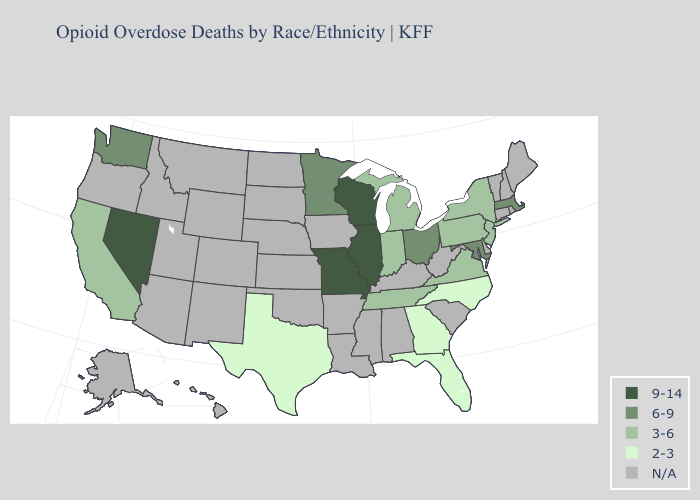Name the states that have a value in the range N/A?
Answer briefly. Alabama, Alaska, Arizona, Arkansas, Colorado, Connecticut, Delaware, Hawaii, Idaho, Iowa, Kansas, Kentucky, Louisiana, Maine, Mississippi, Montana, Nebraska, New Hampshire, New Mexico, North Dakota, Oklahoma, Oregon, Rhode Island, South Carolina, South Dakota, Utah, Vermont, West Virginia, Wyoming. Name the states that have a value in the range N/A?
Be succinct. Alabama, Alaska, Arizona, Arkansas, Colorado, Connecticut, Delaware, Hawaii, Idaho, Iowa, Kansas, Kentucky, Louisiana, Maine, Mississippi, Montana, Nebraska, New Hampshire, New Mexico, North Dakota, Oklahoma, Oregon, Rhode Island, South Carolina, South Dakota, Utah, Vermont, West Virginia, Wyoming. What is the highest value in the West ?
Keep it brief. 9-14. Which states hav the highest value in the South?
Short answer required. Maryland. Does Missouri have the highest value in the USA?
Keep it brief. Yes. Name the states that have a value in the range 9-14?
Be succinct. Illinois, Missouri, Nevada, Wisconsin. Is the legend a continuous bar?
Answer briefly. No. What is the highest value in states that border Idaho?
Give a very brief answer. 9-14. What is the value of Virginia?
Give a very brief answer. 3-6. Name the states that have a value in the range 3-6?
Be succinct. California, Indiana, Michigan, New Jersey, New York, Pennsylvania, Tennessee, Virginia. What is the highest value in states that border New York?
Keep it brief. 6-9. Name the states that have a value in the range 6-9?
Keep it brief. Maryland, Massachusetts, Minnesota, Ohio, Washington. Name the states that have a value in the range 9-14?
Answer briefly. Illinois, Missouri, Nevada, Wisconsin. 